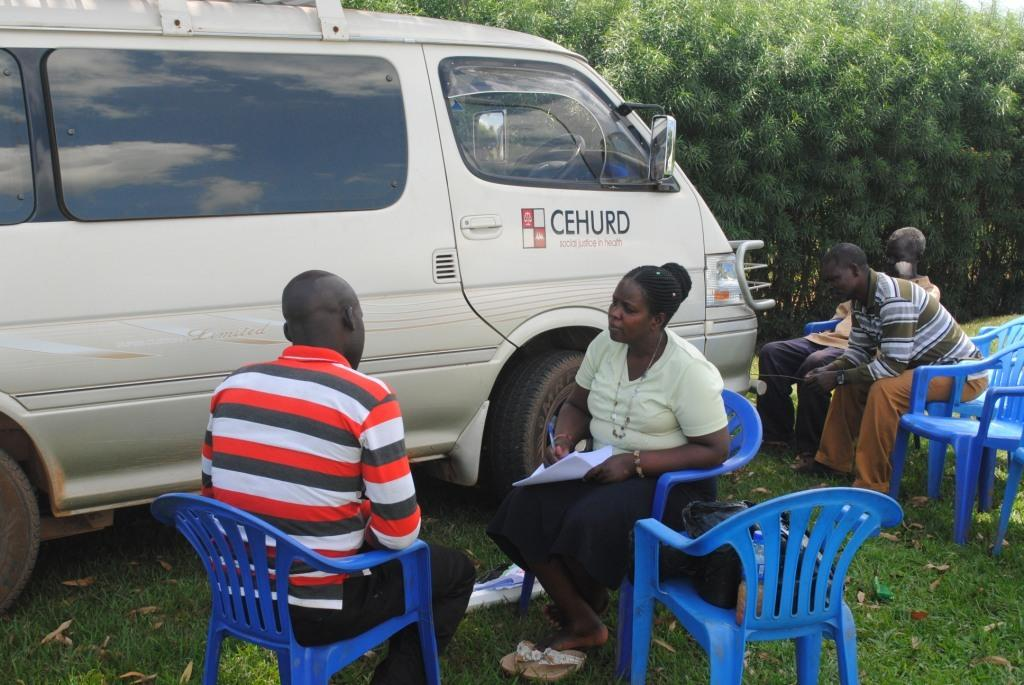What are the people in the image doing? There is a group of persons sitting on chairs in the image. What type of surface are the chairs placed on? The grass is visible in the image, so the chairs are likely placed on the grass. What else can be seen in the image besides the group of persons? There is a vehicle and trees visible in the image. How many pizzas are being served to the prisoners in the image? There is no reference to a prison or pizzas in the image; it features a group of persons sitting on chairs with a vehicle and trees in the background. 